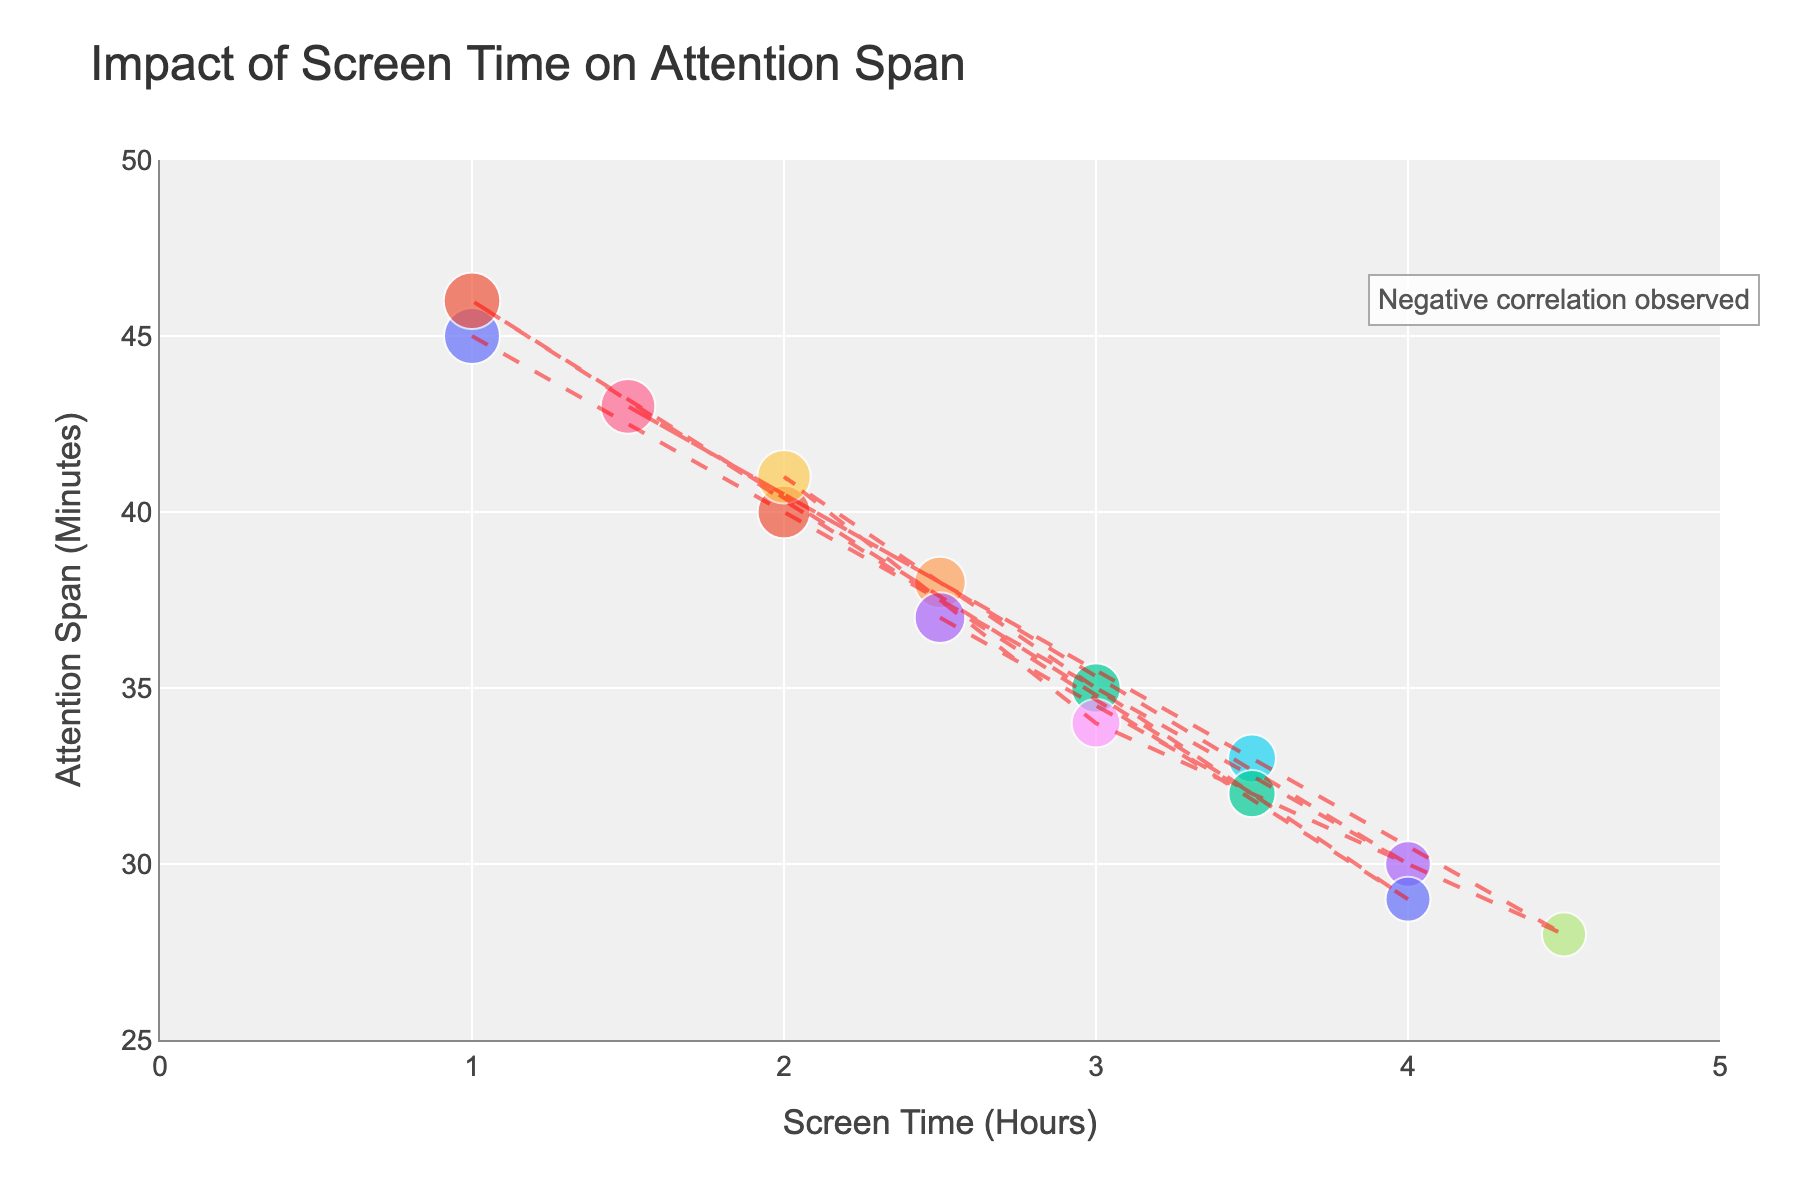What is the title of the scatter plot? The title of the plot is generally located at the top and provides a summary of what the plot is about. In this case, it clearly states 'Impact of Screen Time on Attention Span'.
Answer: Impact of Screen Time on Attention Span What are the labels for the x-axis and y-axis? These labels give information about the variables plotted on each axis. The x-axis is labeled 'Screen Time (Hours)' and the y-axis is labeled 'Attention Span (Minutes)'.
Answer: Screen Time (Hours) and Attention Span (Minutes) How many data points are plotted in the scatter plot? To find the number of data points, count the individual scatter points in the figure. Each data point represents a participant. There are 14 names listed in the hover data, indicating 14 points.
Answer: 14 Who has the highest attention span, and what is their screen time? Check for the highest position on the y-axis. The point is at 46 minutes for Benjamin, and the corresponding x-axis value (screen time) is 1 hour.
Answer: Benjamin, 1 hour Is there a participant with 4 hours of screen time? If so, what is their attention span? Locate the point at 4 hours on the x-axis and see where it intersects on the y-axis. Olivia’s attention span is 30 minutes.
Answer: Yes, Olivia with 30 minutes What is the general trend or correlation observed in the scatter plot? The trendline added to the plot shows the overall direction. The annotation also states "Negative correlation observed," indicating as screen time increases, attention span decreases.
Answer: Negative correlation How does Sophia’s attention span compare to Noah’s? Locate Sophia and Noah on the scatter plot. Sophia has a screen time of 4.5 hours (28 minutes attention span), and Noah has 2.5 hours (38 minutes attention span). Difference = 38 - 28 = 10 minutes.
Answer: Sophia's attention span is 10 minutes less than Noah's What is the average attention span for participants with 3 hours of screen time or more? Identify participants with 3 or more hours of screen time (Liam, Olivia, Ava, James, Charlotte, Evelyn, Sophia), their attention spans are 35, 30, 33, 34, 29, 32, 28 respectively. Sum these values and divide by 7. (35+30+33+34+29+32+28)/7 = 221/7
Answer: 31.57 minutes How many participants have more than 2 hours but less than 3 hours of screen time? List the participants within the range >2 hours and <3 hours, which are Noah and Mason.
Answer: 2 